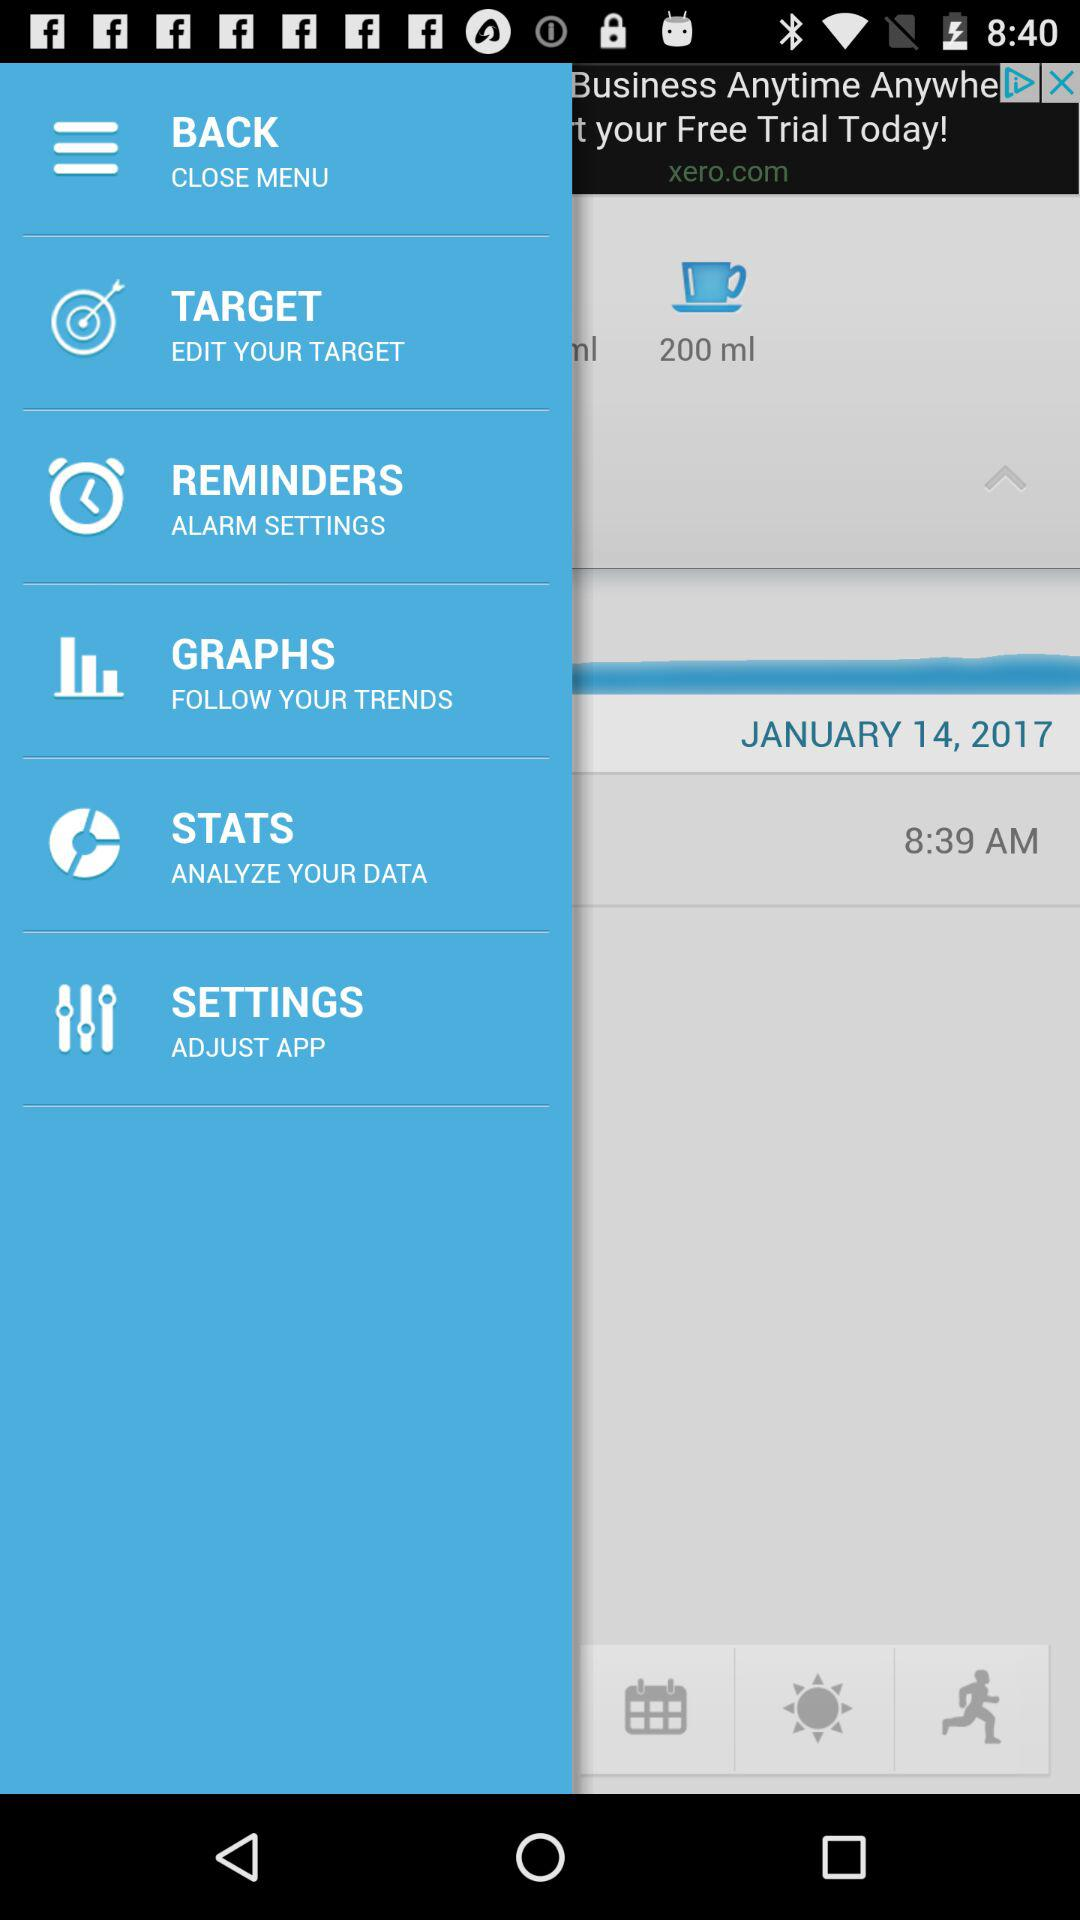What is the date? The date is January 14, 2017. 